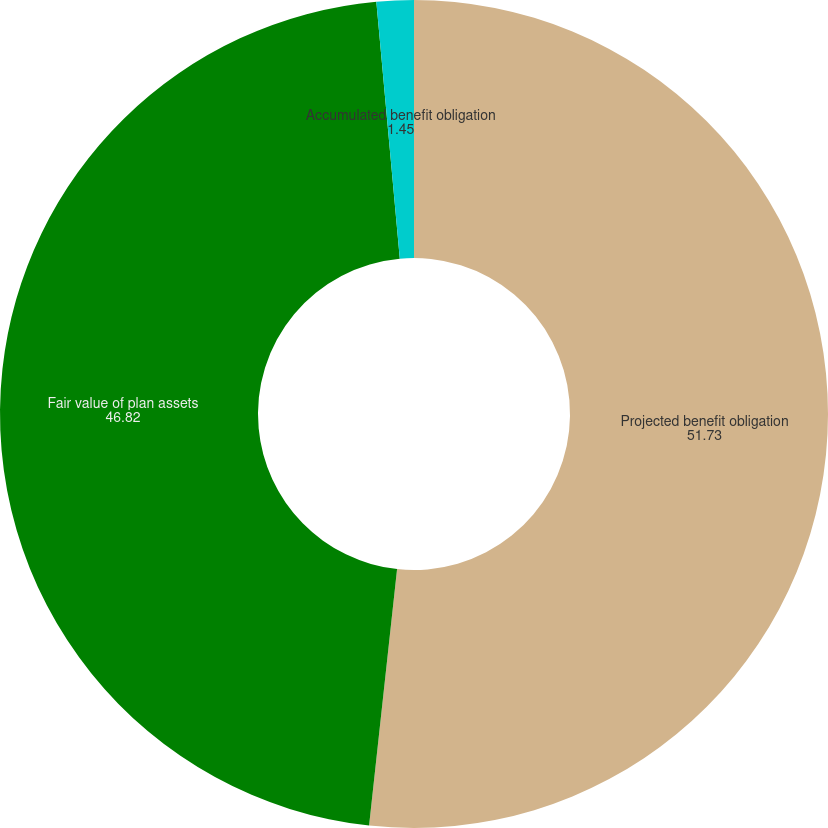Convert chart. <chart><loc_0><loc_0><loc_500><loc_500><pie_chart><fcel>Projected benefit obligation<fcel>Fair value of plan assets<fcel>Accumulated benefit obligation<nl><fcel>51.73%<fcel>46.82%<fcel>1.45%<nl></chart> 